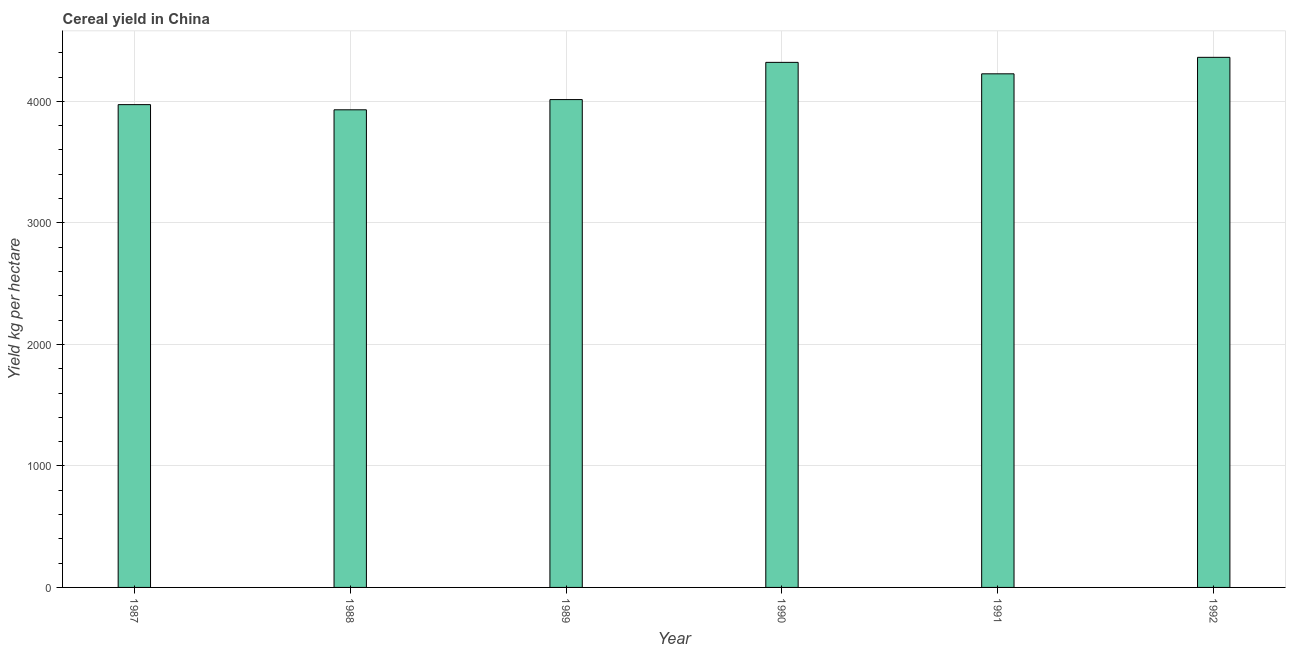Does the graph contain grids?
Give a very brief answer. Yes. What is the title of the graph?
Your response must be concise. Cereal yield in China. What is the label or title of the X-axis?
Offer a very short reply. Year. What is the label or title of the Y-axis?
Give a very brief answer. Yield kg per hectare. What is the cereal yield in 1987?
Your response must be concise. 3973.11. Across all years, what is the maximum cereal yield?
Your answer should be compact. 4362.46. Across all years, what is the minimum cereal yield?
Offer a terse response. 3930.56. What is the sum of the cereal yield?
Keep it short and to the point. 2.48e+04. What is the difference between the cereal yield in 1987 and 1992?
Offer a very short reply. -389.35. What is the average cereal yield per year?
Keep it short and to the point. 4138.09. What is the median cereal yield?
Offer a terse response. 4120.74. What is the ratio of the cereal yield in 1988 to that in 1992?
Offer a very short reply. 0.9. Is the cereal yield in 1989 less than that in 1990?
Provide a short and direct response. Yes. What is the difference between the highest and the second highest cereal yield?
Offer a terse response. 41.51. What is the difference between the highest and the lowest cereal yield?
Your answer should be compact. 431.9. Are all the bars in the graph horizontal?
Provide a succinct answer. No. How many years are there in the graph?
Ensure brevity in your answer.  6. Are the values on the major ticks of Y-axis written in scientific E-notation?
Provide a short and direct response. No. What is the Yield kg per hectare in 1987?
Give a very brief answer. 3973.11. What is the Yield kg per hectare in 1988?
Your response must be concise. 3930.56. What is the Yield kg per hectare in 1989?
Your response must be concise. 4014.68. What is the Yield kg per hectare in 1990?
Offer a terse response. 4320.94. What is the Yield kg per hectare of 1991?
Offer a very short reply. 4226.79. What is the Yield kg per hectare of 1992?
Offer a very short reply. 4362.46. What is the difference between the Yield kg per hectare in 1987 and 1988?
Ensure brevity in your answer.  42.55. What is the difference between the Yield kg per hectare in 1987 and 1989?
Offer a very short reply. -41.57. What is the difference between the Yield kg per hectare in 1987 and 1990?
Provide a succinct answer. -347.83. What is the difference between the Yield kg per hectare in 1987 and 1991?
Keep it short and to the point. -253.68. What is the difference between the Yield kg per hectare in 1987 and 1992?
Give a very brief answer. -389.35. What is the difference between the Yield kg per hectare in 1988 and 1989?
Ensure brevity in your answer.  -84.12. What is the difference between the Yield kg per hectare in 1988 and 1990?
Provide a short and direct response. -390.38. What is the difference between the Yield kg per hectare in 1988 and 1991?
Your answer should be compact. -296.23. What is the difference between the Yield kg per hectare in 1988 and 1992?
Give a very brief answer. -431.9. What is the difference between the Yield kg per hectare in 1989 and 1990?
Provide a short and direct response. -306.26. What is the difference between the Yield kg per hectare in 1989 and 1991?
Keep it short and to the point. -212.11. What is the difference between the Yield kg per hectare in 1989 and 1992?
Offer a very short reply. -347.77. What is the difference between the Yield kg per hectare in 1990 and 1991?
Offer a very short reply. 94.15. What is the difference between the Yield kg per hectare in 1990 and 1992?
Give a very brief answer. -41.51. What is the difference between the Yield kg per hectare in 1991 and 1992?
Give a very brief answer. -135.67. What is the ratio of the Yield kg per hectare in 1987 to that in 1988?
Ensure brevity in your answer.  1.01. What is the ratio of the Yield kg per hectare in 1987 to that in 1989?
Offer a terse response. 0.99. What is the ratio of the Yield kg per hectare in 1987 to that in 1990?
Keep it short and to the point. 0.92. What is the ratio of the Yield kg per hectare in 1987 to that in 1991?
Give a very brief answer. 0.94. What is the ratio of the Yield kg per hectare in 1987 to that in 1992?
Offer a very short reply. 0.91. What is the ratio of the Yield kg per hectare in 1988 to that in 1989?
Offer a very short reply. 0.98. What is the ratio of the Yield kg per hectare in 1988 to that in 1990?
Your response must be concise. 0.91. What is the ratio of the Yield kg per hectare in 1988 to that in 1991?
Offer a terse response. 0.93. What is the ratio of the Yield kg per hectare in 1988 to that in 1992?
Your response must be concise. 0.9. What is the ratio of the Yield kg per hectare in 1989 to that in 1990?
Your answer should be compact. 0.93. What is the ratio of the Yield kg per hectare in 1989 to that in 1991?
Offer a very short reply. 0.95. What is the ratio of the Yield kg per hectare in 1990 to that in 1991?
Provide a short and direct response. 1.02. What is the ratio of the Yield kg per hectare in 1990 to that in 1992?
Offer a terse response. 0.99. What is the ratio of the Yield kg per hectare in 1991 to that in 1992?
Keep it short and to the point. 0.97. 